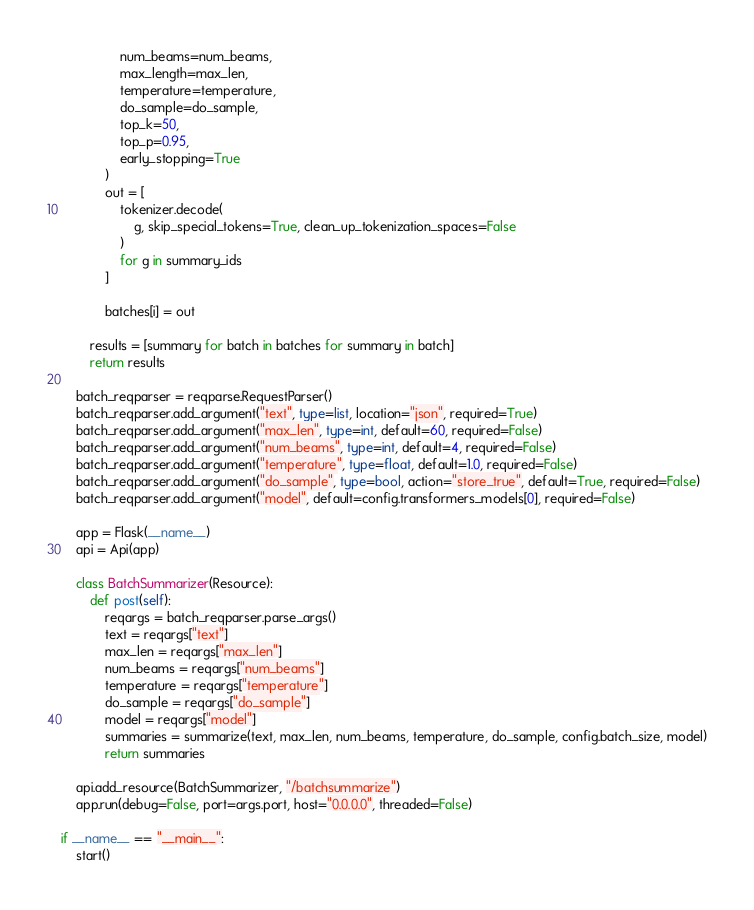<code> <loc_0><loc_0><loc_500><loc_500><_Python_>                num_beams=num_beams,
                max_length=max_len,
                temperature=temperature,
                do_sample=do_sample,
                top_k=50,
                top_p=0.95,
                early_stopping=True
            )
            out = [
                tokenizer.decode(
                    g, skip_special_tokens=True, clean_up_tokenization_spaces=False
                )
                for g in summary_ids
            ]

            batches[i] = out

        results = [summary for batch in batches for summary in batch]
        return results

    batch_reqparser = reqparse.RequestParser()
    batch_reqparser.add_argument("text", type=list, location="json", required=True)
    batch_reqparser.add_argument("max_len", type=int, default=60, required=False)
    batch_reqparser.add_argument("num_beams", type=int, default=4, required=False)
    batch_reqparser.add_argument("temperature", type=float, default=1.0, required=False)
    batch_reqparser.add_argument("do_sample", type=bool, action="store_true", default=True, required=False)
    batch_reqparser.add_argument("model", default=config.transformers_models[0], required=False)

    app = Flask(__name__)
    api = Api(app)

    class BatchSummarizer(Resource):
        def post(self):
            reqargs = batch_reqparser.parse_args()
            text = reqargs["text"]
            max_len = reqargs["max_len"]
            num_beams = reqargs["num_beams"]
            temperature = reqargs["temperature"]
            do_sample = reqargs["do_sample"]
            model = reqargs["model"]
            summaries = summarize(text, max_len, num_beams, temperature, do_sample, config.batch_size, model)
            return summaries
        
    api.add_resource(BatchSummarizer, "/batchsummarize")
    app.run(debug=False, port=args.port, host="0.0.0.0", threaded=False)

if __name__ == "__main__":
    start()</code> 